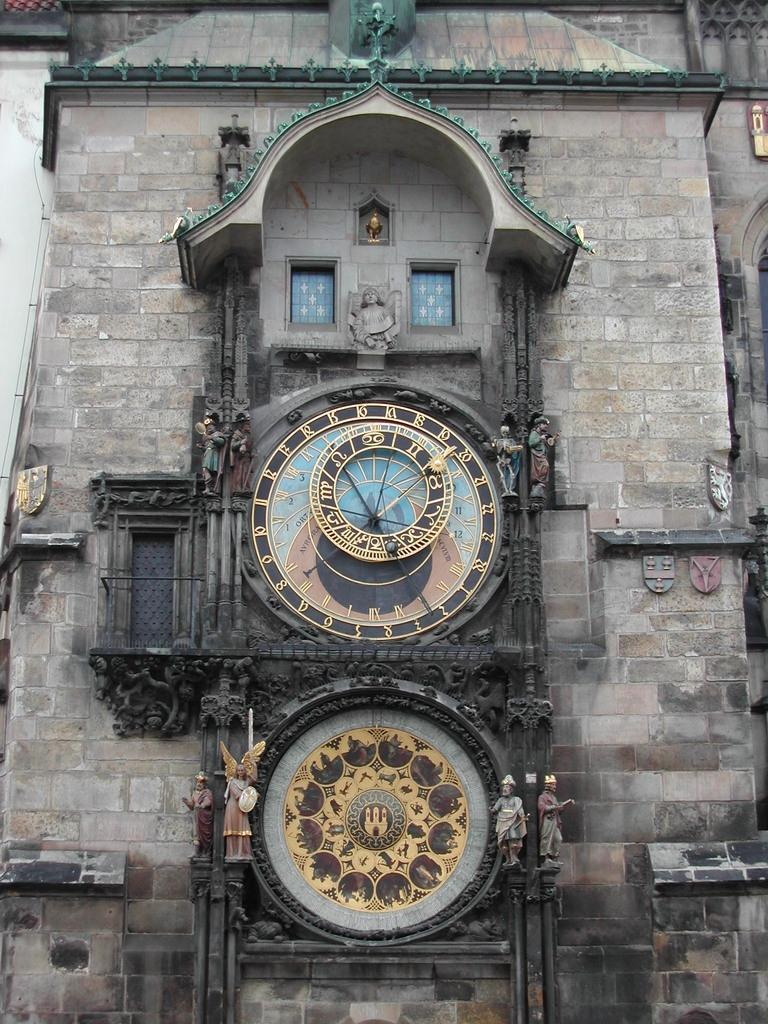<image>
Render a clear and concise summary of the photo. A strange and complicated clock features the numbers 16 and 18 near the top of the face 